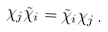<formula> <loc_0><loc_0><loc_500><loc_500>\chi _ { j } \tilde { \chi } _ { i } = \tilde { \chi } _ { i } \chi _ { j } \, .</formula> 